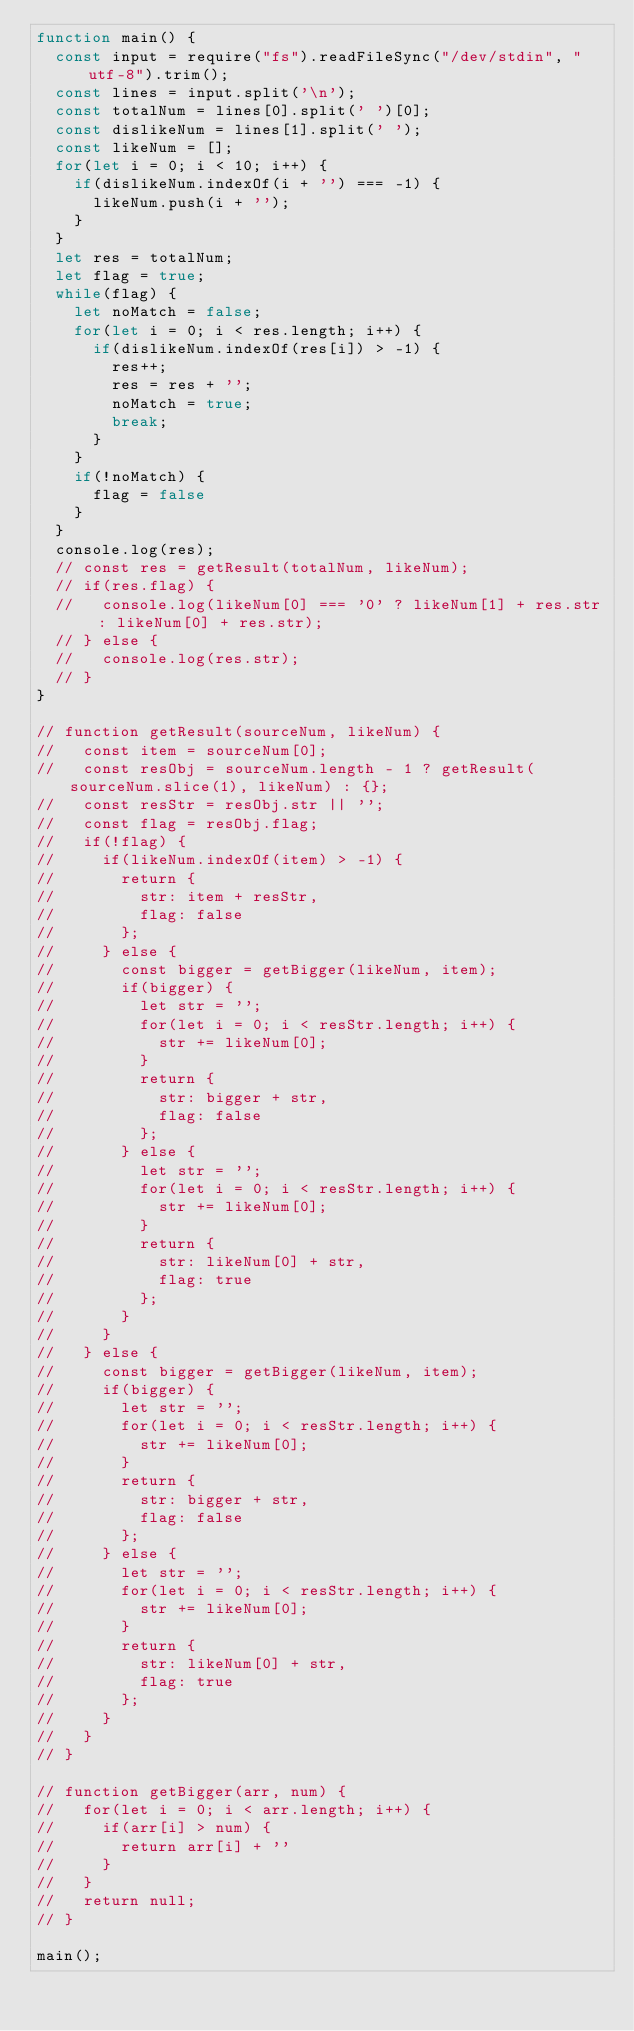<code> <loc_0><loc_0><loc_500><loc_500><_JavaScript_>function main() {
  const input = require("fs").readFileSync("/dev/stdin", "utf-8").trim();
  const lines = input.split('\n');
  const totalNum = lines[0].split(' ')[0];
  const dislikeNum = lines[1].split(' ');
  const likeNum = [];
  for(let i = 0; i < 10; i++) {
    if(dislikeNum.indexOf(i + '') === -1) {
      likeNum.push(i + '');
    }
  }
  let res = totalNum;
  let flag = true;
  while(flag) {
    let noMatch = false;
    for(let i = 0; i < res.length; i++) {
      if(dislikeNum.indexOf(res[i]) > -1) {
        res++;
        res = res + '';
        noMatch = true;
        break;
      }
    }
    if(!noMatch) {
      flag = false
    }
  }
  console.log(res);
  // const res = getResult(totalNum, likeNum);
  // if(res.flag) {
  //   console.log(likeNum[0] === '0' ? likeNum[1] + res.str : likeNum[0] + res.str);
  // } else {
  //   console.log(res.str);
  // }
}

// function getResult(sourceNum, likeNum) {
//   const item = sourceNum[0];
//   const resObj = sourceNum.length - 1 ? getResult(sourceNum.slice(1), likeNum) : {};
//   const resStr = resObj.str || '';
//   const flag = resObj.flag;
//   if(!flag) {
//     if(likeNum.indexOf(item) > -1) {
//       return {
//         str: item + resStr,
//         flag: false
//       };
//     } else {
//       const bigger = getBigger(likeNum, item);
//       if(bigger) {
//         let str = '';
//         for(let i = 0; i < resStr.length; i++) {
//           str += likeNum[0];
//         }
//         return {
//           str: bigger + str,
//           flag: false
//         };
//       } else {
//         let str = '';
//         for(let i = 0; i < resStr.length; i++) {
//           str += likeNum[0];
//         }
//         return {
//           str: likeNum[0] + str,
//           flag: true
//         };
//       }
//     }
//   } else {
//     const bigger = getBigger(likeNum, item);
//     if(bigger) {
//       let str = '';
//       for(let i = 0; i < resStr.length; i++) {
//         str += likeNum[0];
//       }
//       return {
//         str: bigger + str,
//         flag: false
//       };
//     } else {
//       let str = '';
//       for(let i = 0; i < resStr.length; i++) {
//         str += likeNum[0];
//       }
//       return {
//         str: likeNum[0] + str,
//         flag: true
//       };
//     }
//   }
// }

// function getBigger(arr, num) {
//   for(let i = 0; i < arr.length; i++) {
//     if(arr[i] > num) {
//       return arr[i] + ''
//     }
//   }
//   return null;
// }

main();
</code> 